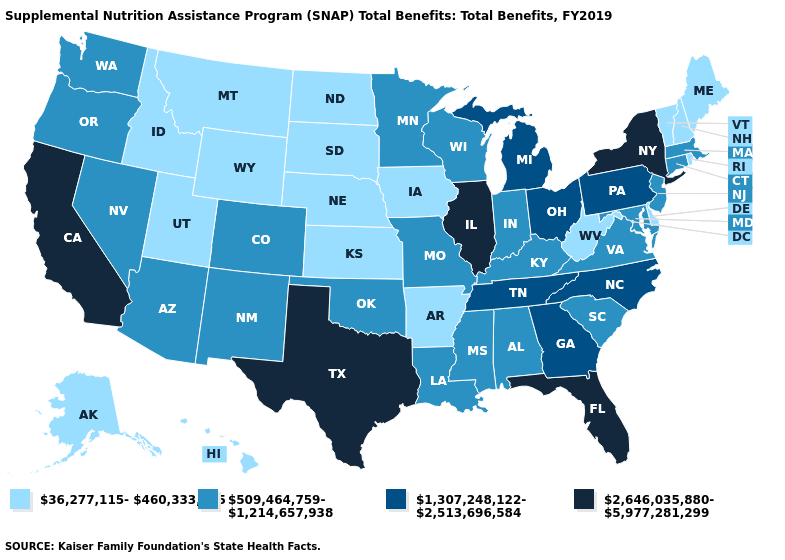What is the lowest value in the West?
Keep it brief. 36,277,115-460,333,605. What is the value of Michigan?
Answer briefly. 1,307,248,122-2,513,696,584. What is the value of South Dakota?
Quick response, please. 36,277,115-460,333,605. What is the highest value in states that border Massachusetts?
Concise answer only. 2,646,035,880-5,977,281,299. What is the lowest value in the Northeast?
Answer briefly. 36,277,115-460,333,605. What is the highest value in the Northeast ?
Concise answer only. 2,646,035,880-5,977,281,299. Does the first symbol in the legend represent the smallest category?
Quick response, please. Yes. Does Maine have the lowest value in the USA?
Give a very brief answer. Yes. Among the states that border Illinois , does Iowa have the highest value?
Write a very short answer. No. Name the states that have a value in the range 2,646,035,880-5,977,281,299?
Write a very short answer. California, Florida, Illinois, New York, Texas. Name the states that have a value in the range 36,277,115-460,333,605?
Write a very short answer. Alaska, Arkansas, Delaware, Hawaii, Idaho, Iowa, Kansas, Maine, Montana, Nebraska, New Hampshire, North Dakota, Rhode Island, South Dakota, Utah, Vermont, West Virginia, Wyoming. What is the highest value in states that border Wyoming?
Answer briefly. 509,464,759-1,214,657,938. Which states have the highest value in the USA?
Give a very brief answer. California, Florida, Illinois, New York, Texas. Does Maryland have the lowest value in the South?
Short answer required. No. 